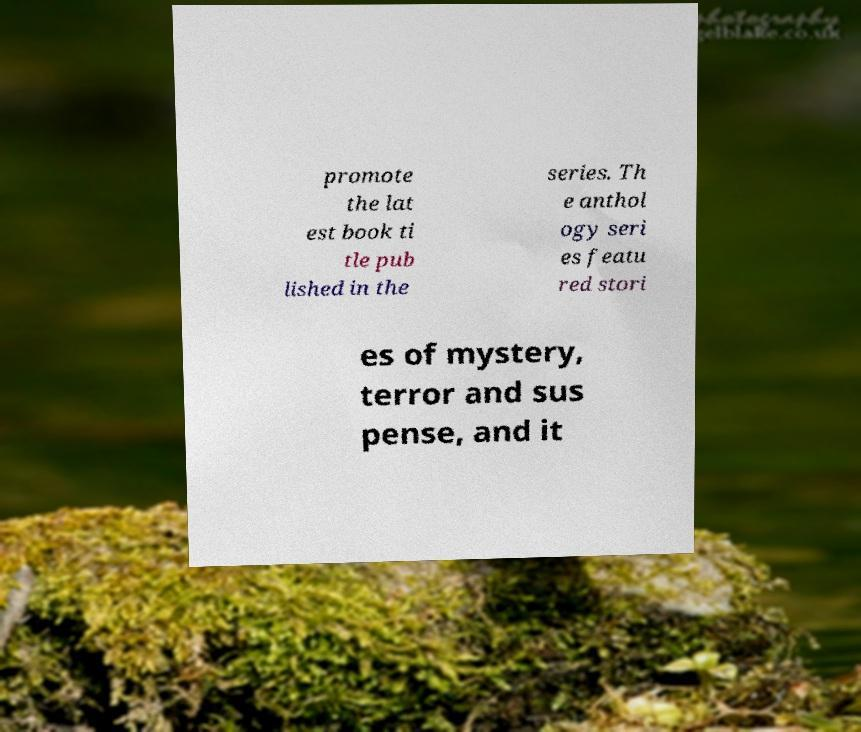Please read and relay the text visible in this image. What does it say? promote the lat est book ti tle pub lished in the series. Th e anthol ogy seri es featu red stori es of mystery, terror and sus pense, and it 